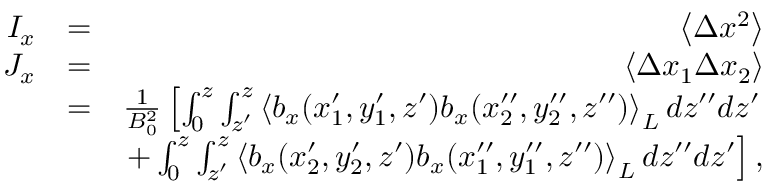<formula> <loc_0><loc_0><loc_500><loc_500>\begin{array} { r l r } { I _ { x } } & { = } & { \left \langle \Delta x ^ { 2 } \right \rangle } \\ { J _ { x } } & { = } & { \left \langle \Delta x _ { 1 } \Delta x _ { 2 } \right \rangle } \\ & { = } & { \frac { 1 } { B _ { 0 } ^ { 2 } } \left [ \int _ { 0 } ^ { z } \int _ { z ^ { \prime } } ^ { z } \left \langle b _ { x } ( x _ { 1 } ^ { \prime } , y _ { 1 } ^ { \prime } , z ^ { \prime } ) b _ { x } ( x _ { 2 } ^ { \prime \prime } , y _ { 2 } ^ { \prime \prime } , z ^ { \prime \prime } ) \right \rangle _ { L } d { z } ^ { \prime \prime } d { z } ^ { \prime } } \\ & { + \int _ { 0 } ^ { z } \int _ { z ^ { \prime } } ^ { z } \left \langle b _ { x } ( x _ { 2 } ^ { \prime } , y _ { 2 } ^ { \prime } , z ^ { \prime } ) b _ { x } ( x _ { 1 } ^ { \prime \prime } , y _ { 1 } ^ { \prime \prime } , z ^ { \prime \prime } ) \right \rangle _ { L } d { z } ^ { \prime \prime } d { z } ^ { \prime } \right ] , } \end{array}</formula> 